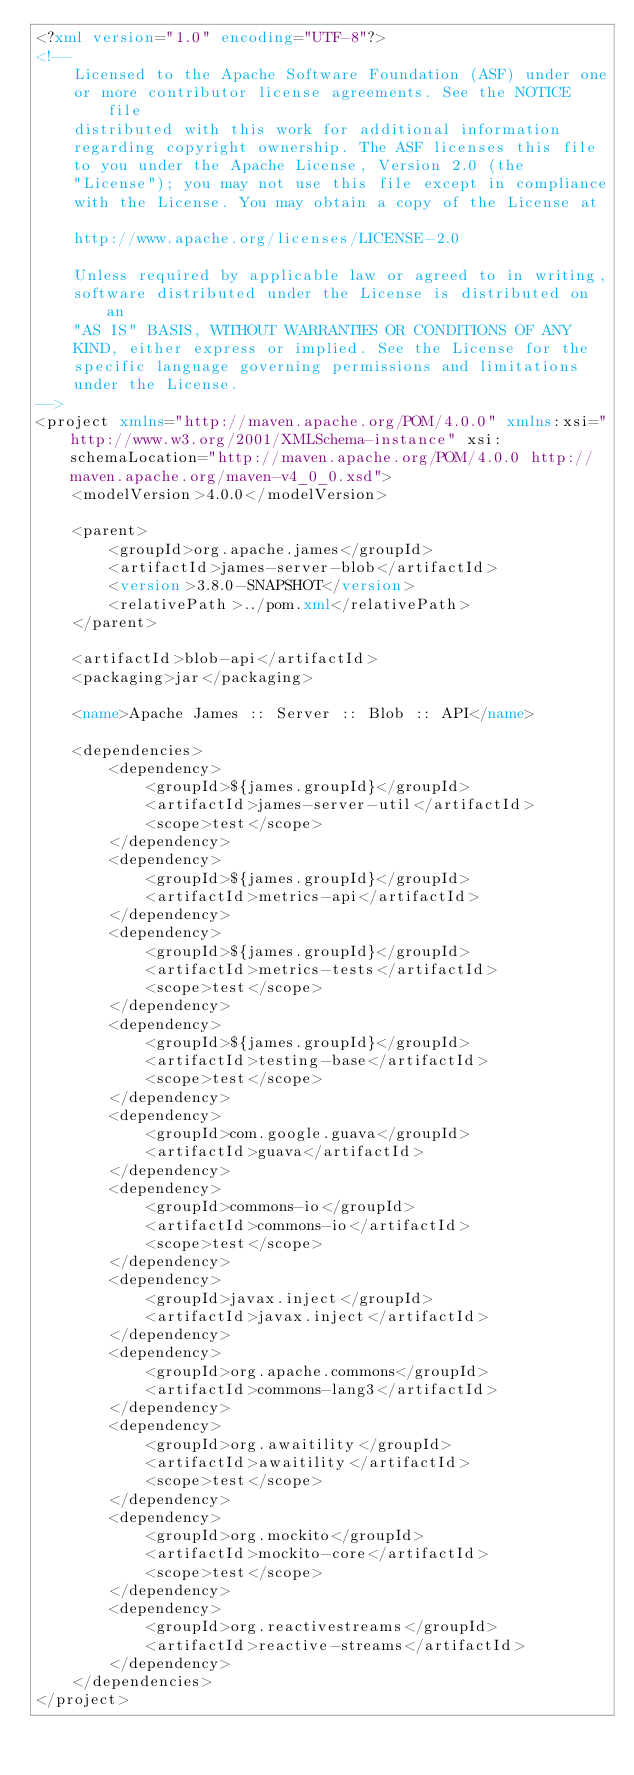Convert code to text. <code><loc_0><loc_0><loc_500><loc_500><_XML_><?xml version="1.0" encoding="UTF-8"?>
<!--
    Licensed to the Apache Software Foundation (ASF) under one
    or more contributor license agreements. See the NOTICE file
    distributed with this work for additional information
    regarding copyright ownership. The ASF licenses this file
    to you under the Apache License, Version 2.0 (the
    "License"); you may not use this file except in compliance
    with the License. You may obtain a copy of the License at

    http://www.apache.org/licenses/LICENSE-2.0

    Unless required by applicable law or agreed to in writing,
    software distributed under the License is distributed on an
    "AS IS" BASIS, WITHOUT WARRANTIES OR CONDITIONS OF ANY
    KIND, either express or implied. See the License for the
    specific language governing permissions and limitations
    under the License.
-->
<project xmlns="http://maven.apache.org/POM/4.0.0" xmlns:xsi="http://www.w3.org/2001/XMLSchema-instance" xsi:schemaLocation="http://maven.apache.org/POM/4.0.0 http://maven.apache.org/maven-v4_0_0.xsd">
    <modelVersion>4.0.0</modelVersion>

    <parent>
        <groupId>org.apache.james</groupId>
        <artifactId>james-server-blob</artifactId>
        <version>3.8.0-SNAPSHOT</version>
        <relativePath>../pom.xml</relativePath>
    </parent>

    <artifactId>blob-api</artifactId>
    <packaging>jar</packaging>

    <name>Apache James :: Server :: Blob :: API</name>

    <dependencies>
        <dependency>
            <groupId>${james.groupId}</groupId>
            <artifactId>james-server-util</artifactId>
            <scope>test</scope>
        </dependency>
        <dependency>
            <groupId>${james.groupId}</groupId>
            <artifactId>metrics-api</artifactId>
        </dependency>
        <dependency>
            <groupId>${james.groupId}</groupId>
            <artifactId>metrics-tests</artifactId>
            <scope>test</scope>
        </dependency>
        <dependency>
            <groupId>${james.groupId}</groupId>
            <artifactId>testing-base</artifactId>
            <scope>test</scope>
        </dependency>
        <dependency>
            <groupId>com.google.guava</groupId>
            <artifactId>guava</artifactId>
        </dependency>
        <dependency>
            <groupId>commons-io</groupId>
            <artifactId>commons-io</artifactId>
            <scope>test</scope>
        </dependency>
        <dependency>
            <groupId>javax.inject</groupId>
            <artifactId>javax.inject</artifactId>
        </dependency>
        <dependency>
            <groupId>org.apache.commons</groupId>
            <artifactId>commons-lang3</artifactId>
        </dependency>
        <dependency>
            <groupId>org.awaitility</groupId>
            <artifactId>awaitility</artifactId>
            <scope>test</scope>
        </dependency>
        <dependency>
            <groupId>org.mockito</groupId>
            <artifactId>mockito-core</artifactId>
            <scope>test</scope>
        </dependency>
        <dependency>
            <groupId>org.reactivestreams</groupId>
            <artifactId>reactive-streams</artifactId>
        </dependency>
    </dependencies>
</project>
</code> 